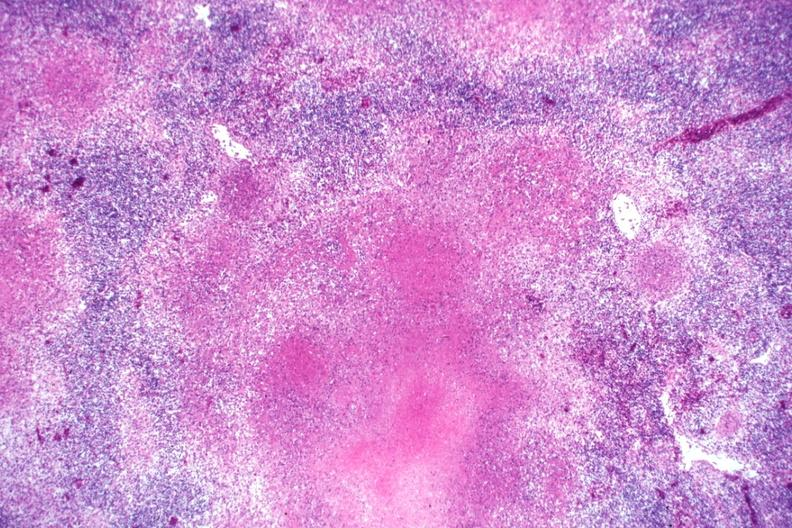s lymph node present?
Answer the question using a single word or phrase. Yes 